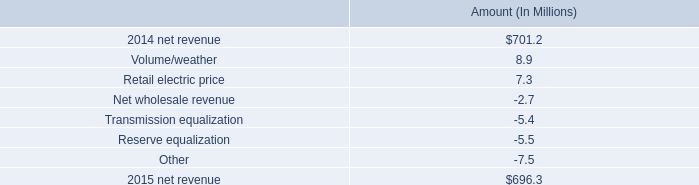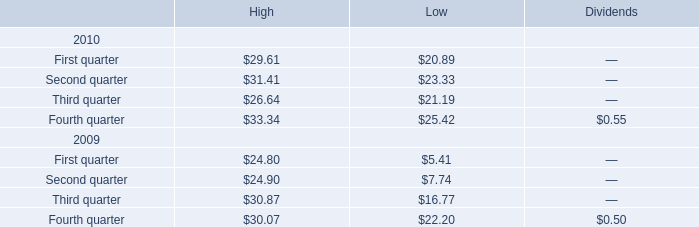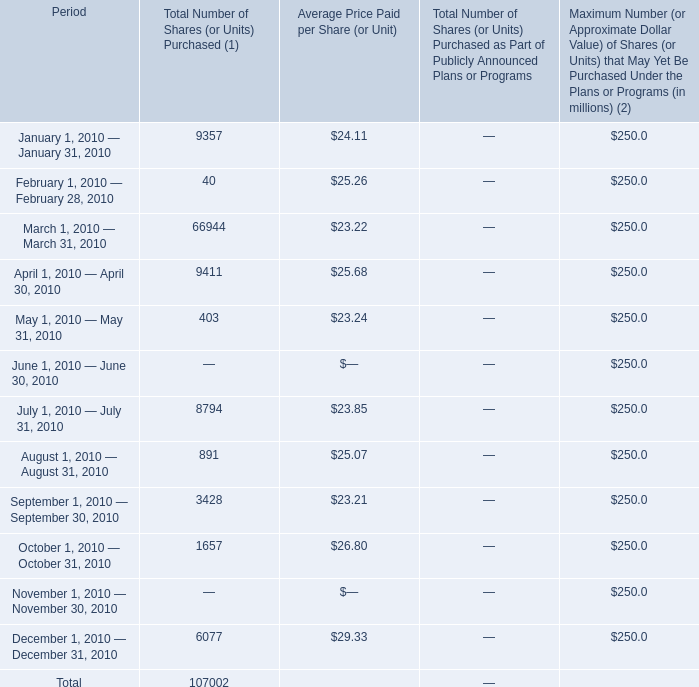Which year is third quarter for high the lowest? 
Answer: 2010. No.what month is Average Price Paid per Share (or Unit) the highest? 
Answer: 12. 